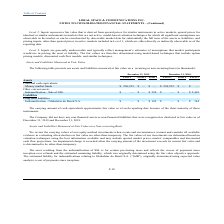From Loral Space Communications's financial document, What are the company's respective Level 3 fair value assets and liabilities in 2018? The document shows two values: $2,410 and $184 (in thousands). From the document: "mnification - Sale of SSL $ — $ — $ 598 $ — $ — $ 2,410 Globalstar do Brasil S.A. $ — $ — $ 145 $ — $ — $ 184..." Also, What are the company's respective Level 3 fair value assets and liabilities in 2019? The document shows two values: $598 and $145 (in thousands). From the document: "mnification - Globalstar do Brasil S.A. $ — $ — $ 145 $ — $ — $ 184 Indemnification - Sale of SSL $ — $ — $ 598 $ — $ — $ 2,410..." Also, What are the respective values of the Level 1 money market funds in 2018 and 2019 respectively? The document shows two values: $254,552 and $256,915 (in thousands). From the document: "Money market funds $ 256,915 $ — $ — $ 254,552 $ — $ — Money market funds $ 256,915 $ — $ — $ 254,552 $ — $ —..." Also, can you calculate: What is the value of the company's net assets in 2019? Based on the calculation: 256,915 + 598 - 145 , the result is 257368 (in thousands). This is based on the information: "Indemnification - Sale of SSL $ — $ — $ 598 $ — $ — $ 2,410 mnification - Globalstar do Brasil S.A. $ — $ — $ 145 $ — $ — $ 184 Money market funds $ 256,915 $ — $ — $ 254,552 $ — $ —..." The key data points involved are: 145, 256,915, 598. Also, can you calculate: What is the value of the company's net assets in 2018? Based on the calculation: 254,552 + 2,410 - 184 , the result is 256778 (in thousands). This is based on the information: "Money market funds $ 256,915 $ — $ — $ 254,552 $ — $ — Globalstar do Brasil S.A. $ — $ — $ 145 $ — $ — $ 184 mnification - Sale of SSL $ — $ — $ 598 $ — $ — $ 2,410..." The key data points involved are: 184, 2,410, 254,552. Also, can you calculate: What is the percentage change in the company's Level 3 liabilities between 2018 and 2019? To answer this question, I need to perform calculations using the financial data. The calculation is: (145 - 184)/184 , which equals -21.2 (percentage). This is based on the information: "Globalstar do Brasil S.A. $ — $ — $ 145 $ — $ — $ 184 mnification - Globalstar do Brasil S.A. $ — $ — $ 145 $ — $ — $ 184..." The key data points involved are: 145, 184. 